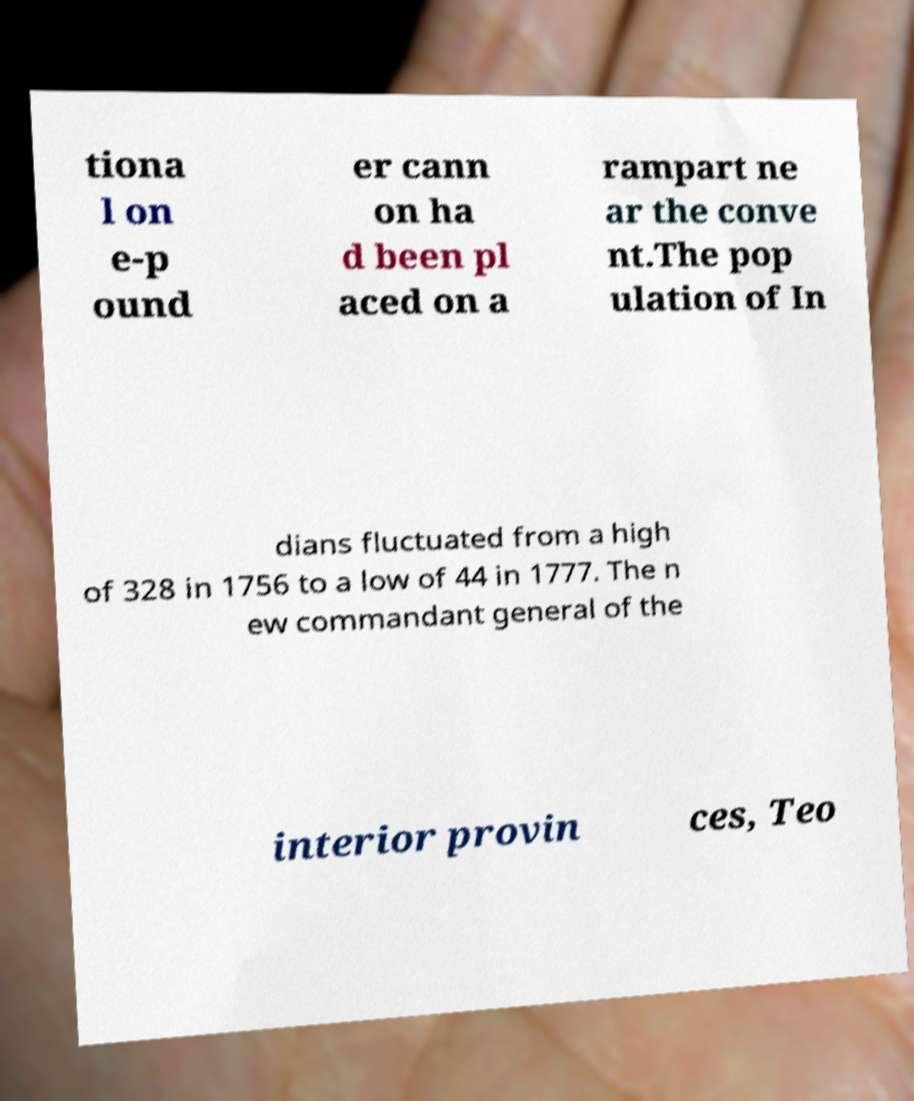There's text embedded in this image that I need extracted. Can you transcribe it verbatim? tiona l on e-p ound er cann on ha d been pl aced on a rampart ne ar the conve nt.The pop ulation of In dians fluctuated from a high of 328 in 1756 to a low of 44 in 1777. The n ew commandant general of the interior provin ces, Teo 